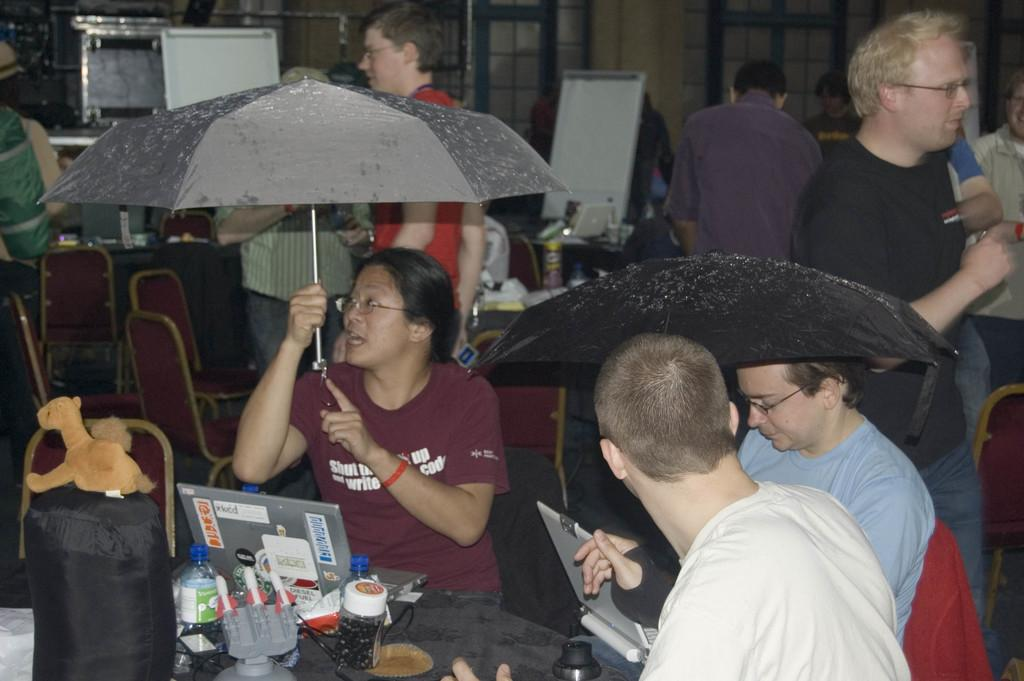What are the people in the image doing? The people in the image are sitting on chairs. What are the people using to protect themselves from the elements? The people are holding umbrellas over themselves. What is on the table in the image? There is a laptop and a water bottle on the table. What might the people be using the laptop for? The people might be using the laptop for work, entertainment, or communication. How many sisters are sitting together in the image? There is no mention of sisters in the image, so we cannot determine the number of sisters present. 